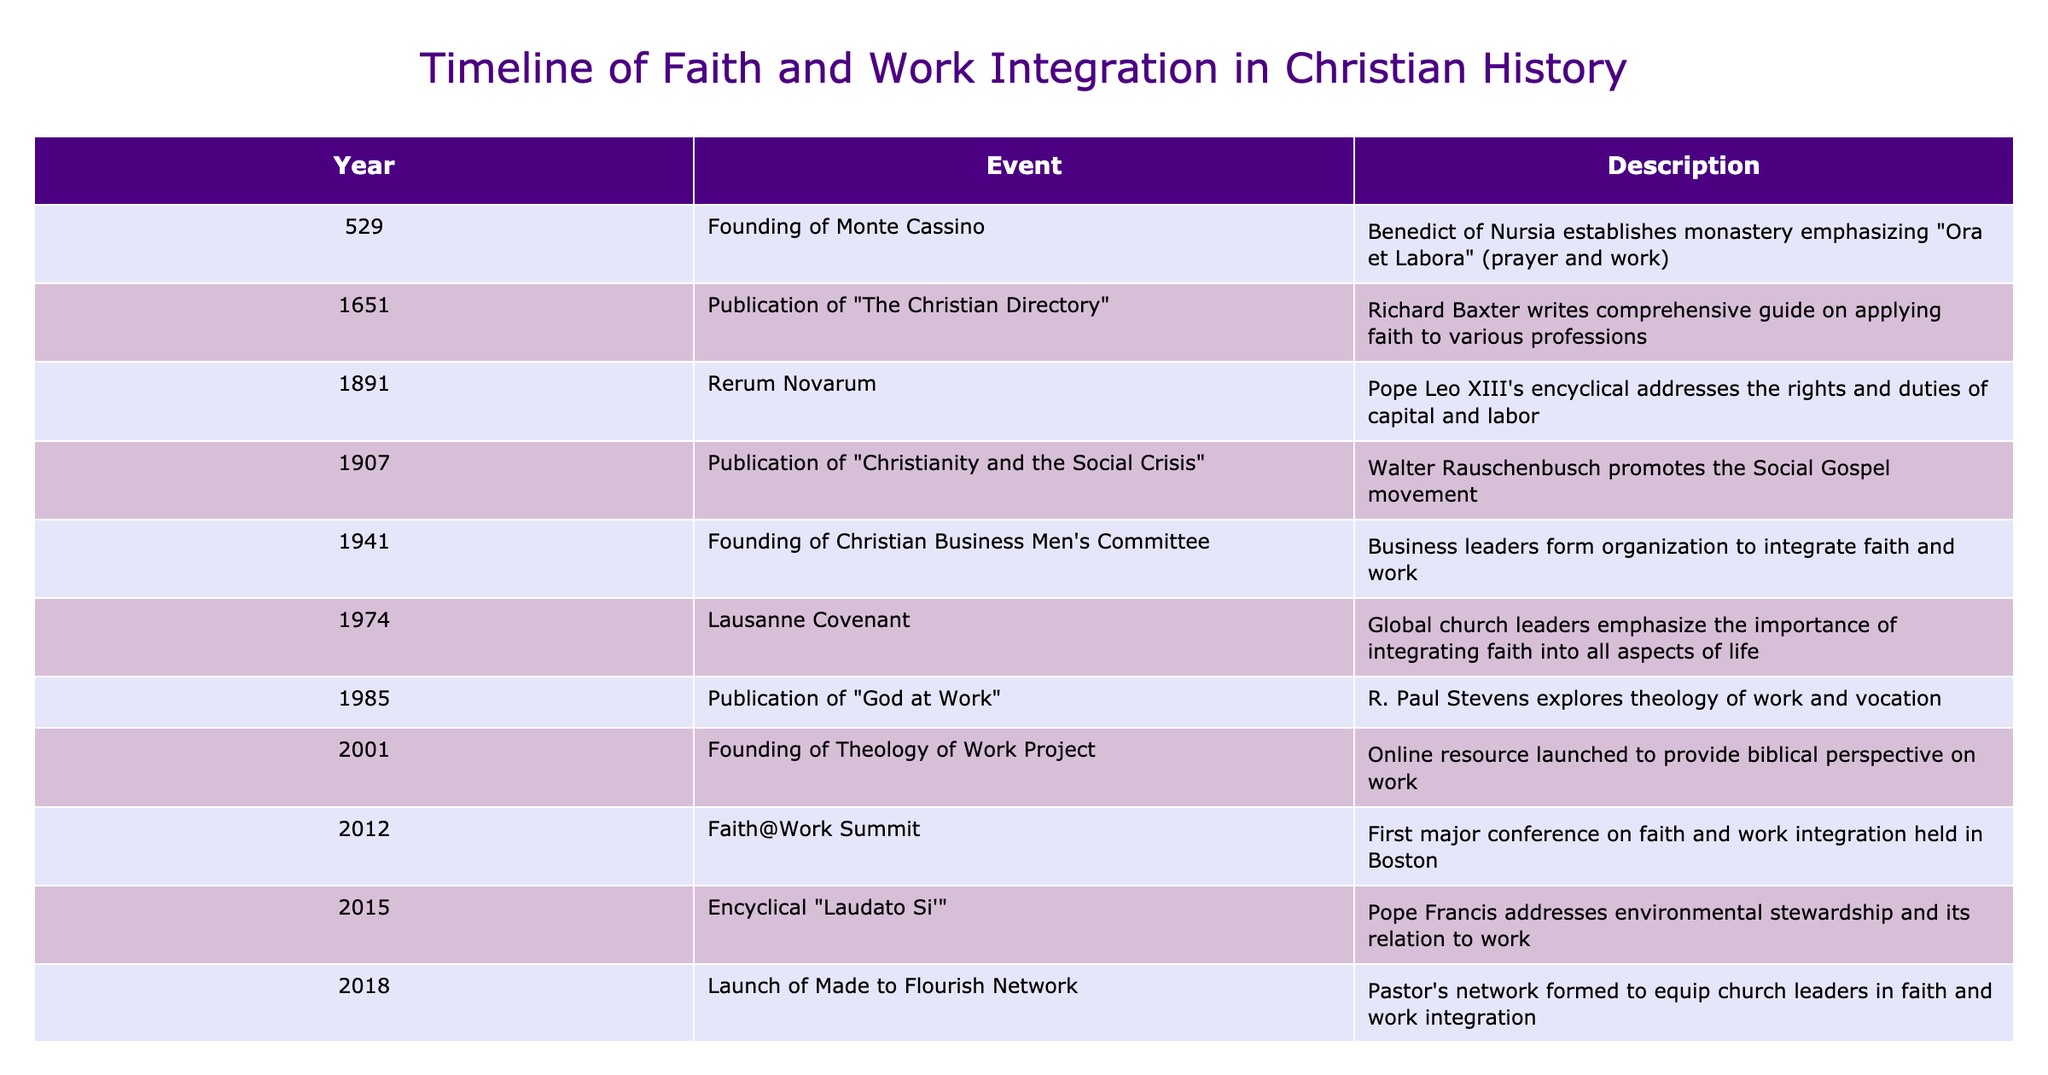What year was the founding of Monte Cassino? The table lists the year of significant events; by finding the row that states "Founding of Monte Cassino," we see it is noted as occurring in the year 529.
Answer: 529 Who wrote "Christianity and the Social Crisis"? The row mentioning "Christianity and the Social Crisis" identifies Walter Rauschenbusch as the author, who promoted the Social Gospel movement.
Answer: Walter Rauschenbusch How many events occurred in the 20th century? By examining the table, the events in the 20th century are as follows: 1907 (Christianity and the Social Crisis), 1941 (Christian Business Men's Committee), 1974 (Lausanne Covenant), 1985 (God at Work), 2001 (Theology of Work Project), 2012 (Faith@Work Summit), 2015 (Laudato Si'), totaling to seven events.
Answer: 7 Did the founding of the Theology of Work Project happen before or after 2000? I can compare the year listed for the Theology of Work Project (2001) with the year 2000; since 2001 is after 2000, the answer is yes, it happened after.
Answer: Yes What was the primary focus of the "Laudato Si'" encyclical? The table describes the "Laudato Si'" encyclical issued by Pope Francis as addressing environmental stewardship and its relation to work, indicating a significant emphasis on both themes.
Answer: Environmental stewardship and work Which event in the table emphasizes the integration of faith into all aspects of life? The event highlighted for emphasizing the integration of faith into every part of life is the Lausanne Covenant from 1974, as noted in the description column.
Answer: Lausanne Covenant (1974) What is the time span between the founding of Monte Cassino and the publication of "The Christian Directory"? Monte Cassino was founded in 529 and "The Christian Directory" was published in 1651. The time between these two years is calculated by subtracting 529 from 1651, resulting in a span of 1122 years.
Answer: 1122 years In what year did the Faith@Work Summit take place, and what significance does this have for modern discussions of work? The Faith@Work Summit occurred in 2012, representing a significant effort to bring together ideas and leaders in the growing conversation about how faith and work integrate in contemporary contexts.
Answer: 2012 How many years separate the event of the COVID-19 pandemic from the founding of the Christian Business Men's Committee? The founding of the Christian Business Men's Committee occurred in 1941, and the COVID-19 pandemic is noted as starting in 2020. The difference in years is computed by taking 2020 and subtracting 1941, resulting in 79 years.
Answer: 79 years 